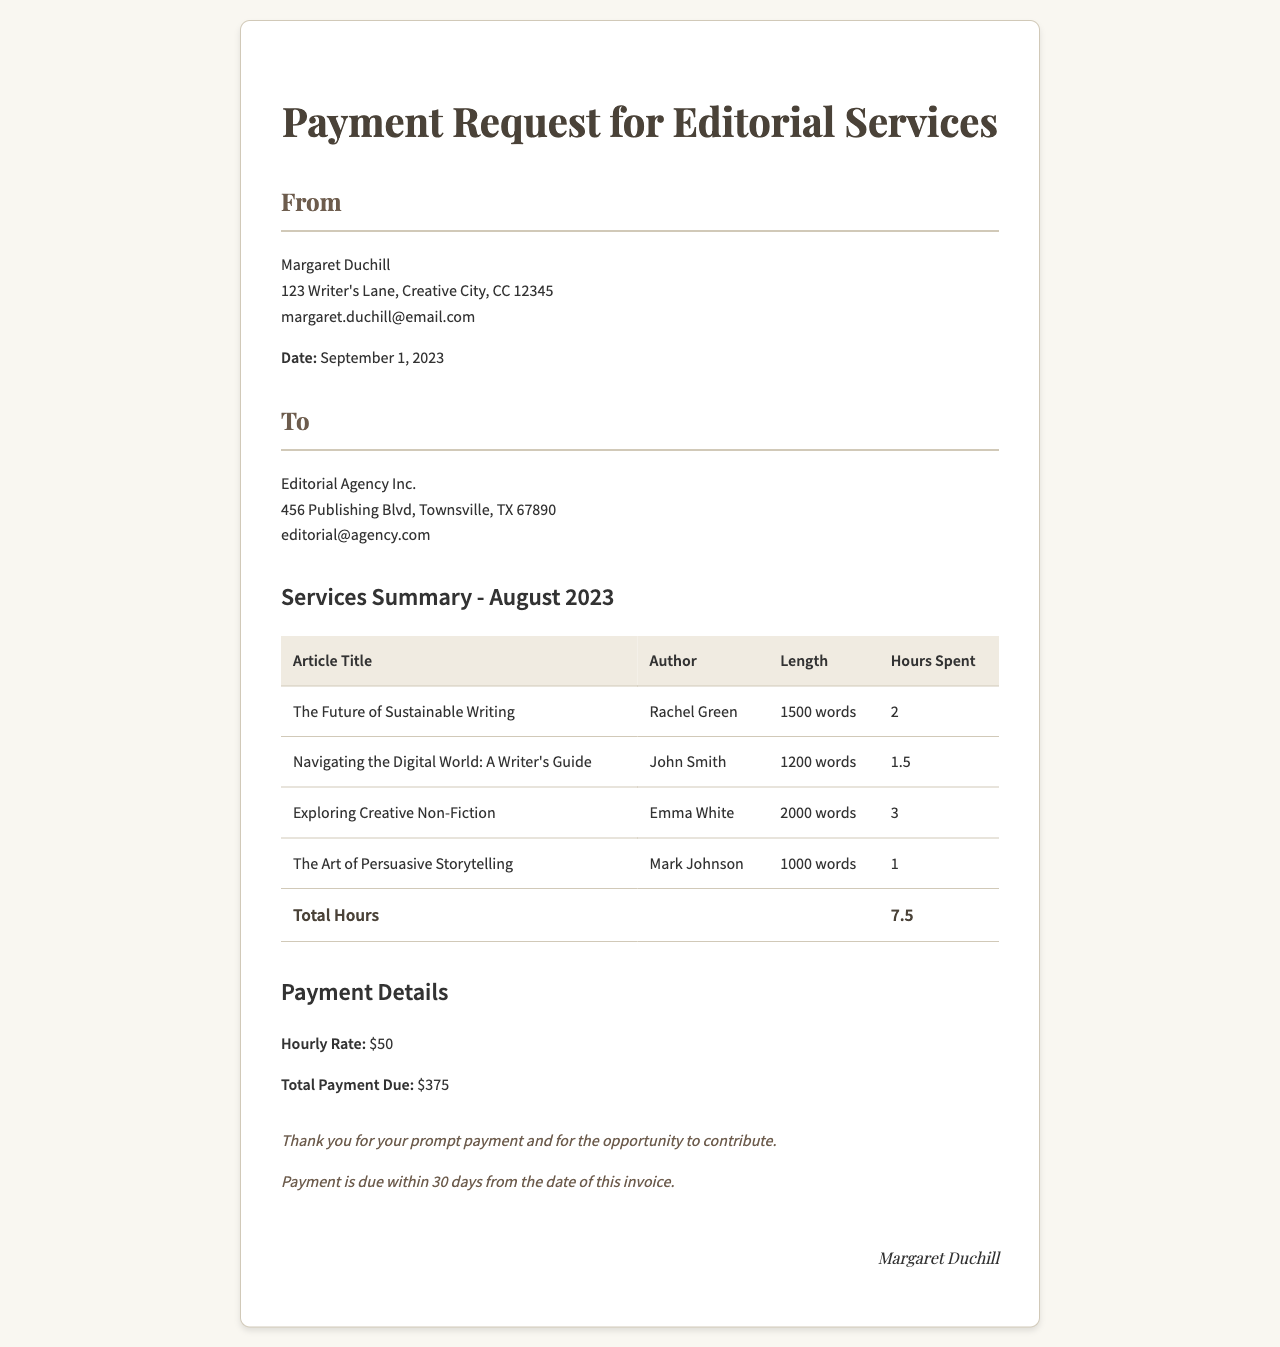what is the date of the invoice? The date of the invoice is mentioned in the header section as September 1, 2023.
Answer: September 1, 2023 what is the total hours spent on editorial services? The total hours spent are calculated in the summary table under "Total Hours," which is listed as 7.5.
Answer: 7.5 who is the author of "The Future of Sustainable Writing"? The author's name for this article is provided in the summary table next to the article title.
Answer: Rachel Green what is the hourly rate for the services rendered? The hourly rate is specified in the payment details as $50.
Answer: $50 what is the total payment due? The total payment due is stated in the payment details section as $375.
Answer: $375 how many articles were reviewed in total? The invoice shows a summary table with four entries, indicating the number of articles reviewed.
Answer: 4 what is the length of the article "Navigating the Digital World: A Writer's Guide"? The length of the article is mentioned next to the article title in the summary table as 1200 words.
Answer: 1200 words within how many days is the payment due? The footer of the invoice notes that payment is due within 30 days from the date of the invoice.
Answer: 30 days 